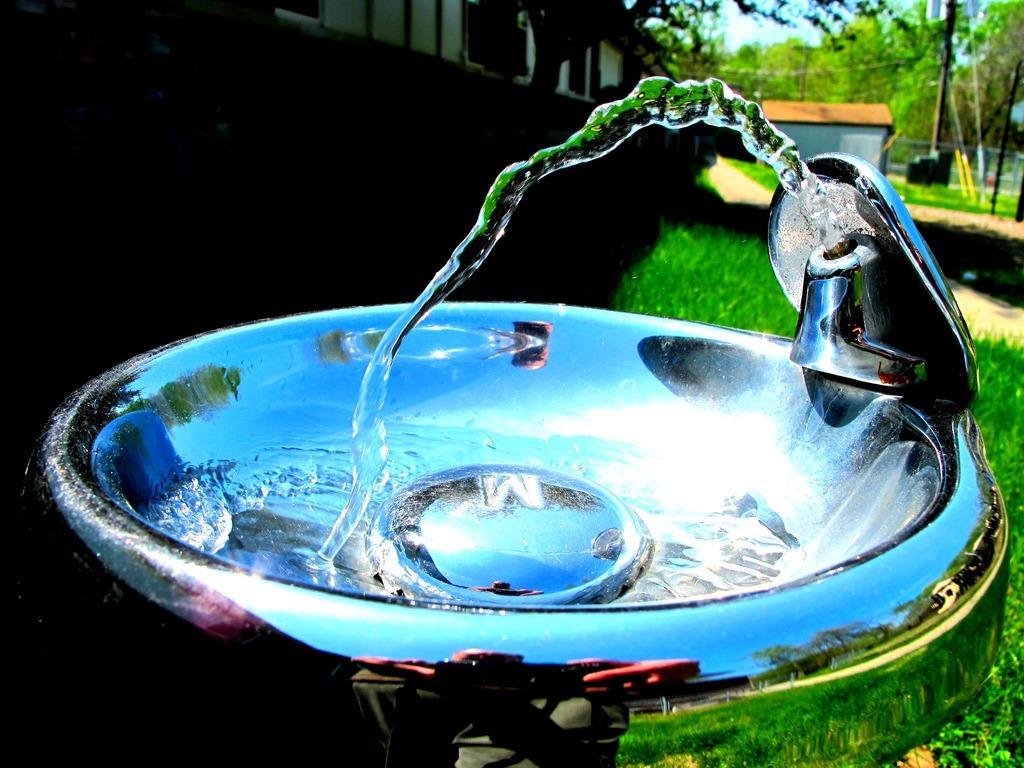Could you give a brief overview of what you see in this image? In front of the image there is a sink and we can see water coming from the tap. At the bottom of the image there is grass on the surface. In the background of the image there are trees, buildings, poles. There is a metal fence. At the top of the image there is sky. 